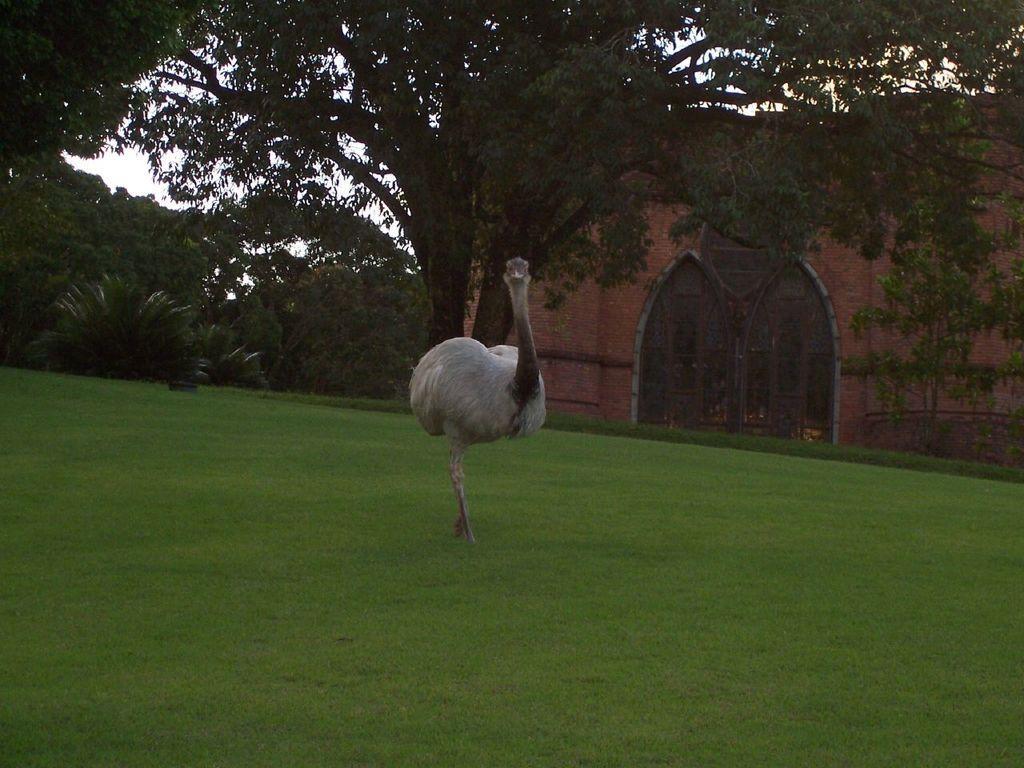Could you give a brief overview of what you see in this image? In this picture we can see an ostrich standing on the ground, at the bottom there is grass, on the right side we can see a house, in the background there are some trees, we can also see the sky in the background. 